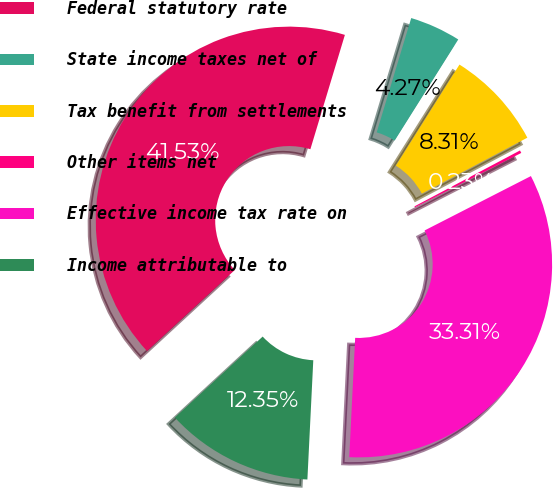Convert chart to OTSL. <chart><loc_0><loc_0><loc_500><loc_500><pie_chart><fcel>Federal statutory rate<fcel>State income taxes net of<fcel>Tax benefit from settlements<fcel>Other items net<fcel>Effective income tax rate on<fcel>Income attributable to<nl><fcel>41.53%<fcel>4.27%<fcel>8.31%<fcel>0.23%<fcel>33.31%<fcel>12.35%<nl></chart> 